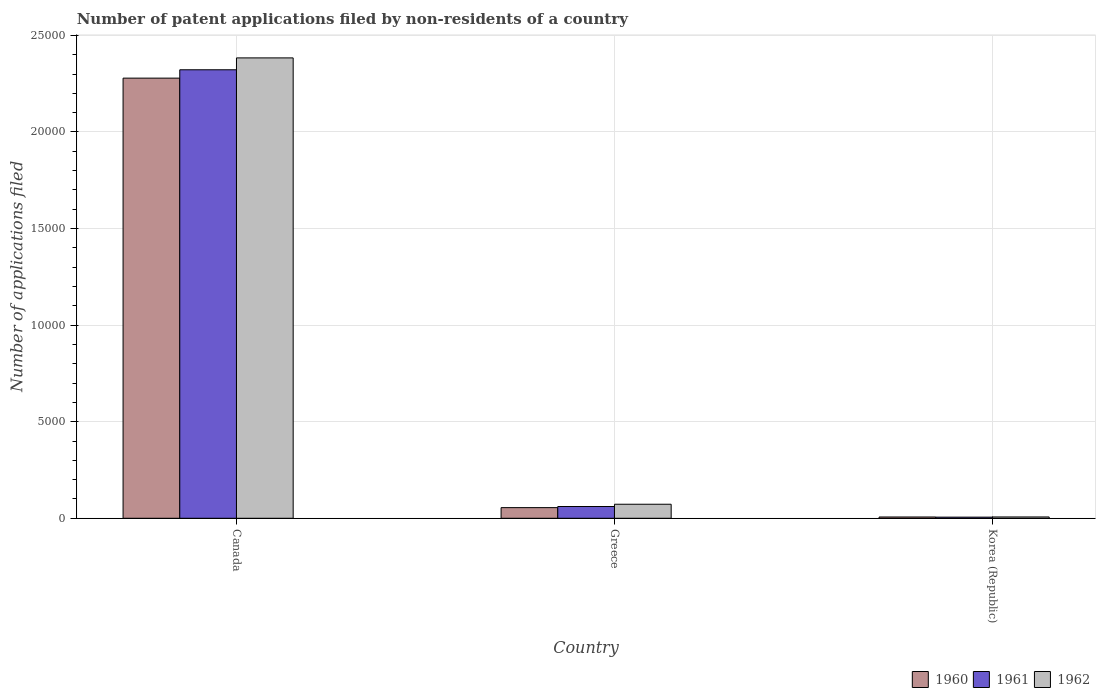How many different coloured bars are there?
Ensure brevity in your answer.  3. Are the number of bars per tick equal to the number of legend labels?
Give a very brief answer. Yes. How many bars are there on the 2nd tick from the left?
Make the answer very short. 3. How many bars are there on the 3rd tick from the right?
Offer a terse response. 3. What is the number of applications filed in 1960 in Canada?
Provide a short and direct response. 2.28e+04. Across all countries, what is the maximum number of applications filed in 1962?
Keep it short and to the point. 2.38e+04. Across all countries, what is the minimum number of applications filed in 1960?
Keep it short and to the point. 66. What is the total number of applications filed in 1960 in the graph?
Give a very brief answer. 2.34e+04. What is the difference between the number of applications filed in 1962 in Canada and that in Greece?
Offer a terse response. 2.31e+04. What is the difference between the number of applications filed in 1960 in Greece and the number of applications filed in 1961 in Korea (Republic)?
Your answer should be very brief. 493. What is the average number of applications filed in 1962 per country?
Your answer should be very brief. 8209.33. What is the difference between the number of applications filed of/in 1961 and number of applications filed of/in 1962 in Canada?
Ensure brevity in your answer.  -615. In how many countries, is the number of applications filed in 1962 greater than 15000?
Give a very brief answer. 1. What is the ratio of the number of applications filed in 1960 in Canada to that in Greece?
Provide a succinct answer. 41.35. Is the number of applications filed in 1962 in Canada less than that in Korea (Republic)?
Make the answer very short. No. What is the difference between the highest and the second highest number of applications filed in 1960?
Give a very brief answer. 2.27e+04. What is the difference between the highest and the lowest number of applications filed in 1960?
Your answer should be compact. 2.27e+04. In how many countries, is the number of applications filed in 1961 greater than the average number of applications filed in 1961 taken over all countries?
Your answer should be very brief. 1. Is the sum of the number of applications filed in 1960 in Canada and Korea (Republic) greater than the maximum number of applications filed in 1962 across all countries?
Your answer should be compact. No. What does the 3rd bar from the right in Greece represents?
Your answer should be compact. 1960. Is it the case that in every country, the sum of the number of applications filed in 1960 and number of applications filed in 1962 is greater than the number of applications filed in 1961?
Offer a terse response. Yes. How many bars are there?
Provide a short and direct response. 9. How many countries are there in the graph?
Ensure brevity in your answer.  3. What is the difference between two consecutive major ticks on the Y-axis?
Your answer should be very brief. 5000. Are the values on the major ticks of Y-axis written in scientific E-notation?
Make the answer very short. No. Where does the legend appear in the graph?
Provide a short and direct response. Bottom right. What is the title of the graph?
Give a very brief answer. Number of patent applications filed by non-residents of a country. Does "2001" appear as one of the legend labels in the graph?
Your answer should be compact. No. What is the label or title of the X-axis?
Offer a terse response. Country. What is the label or title of the Y-axis?
Keep it short and to the point. Number of applications filed. What is the Number of applications filed of 1960 in Canada?
Provide a succinct answer. 2.28e+04. What is the Number of applications filed in 1961 in Canada?
Offer a terse response. 2.32e+04. What is the Number of applications filed in 1962 in Canada?
Your answer should be compact. 2.38e+04. What is the Number of applications filed of 1960 in Greece?
Make the answer very short. 551. What is the Number of applications filed of 1961 in Greece?
Offer a very short reply. 609. What is the Number of applications filed of 1962 in Greece?
Ensure brevity in your answer.  726. What is the Number of applications filed of 1962 in Korea (Republic)?
Keep it short and to the point. 68. Across all countries, what is the maximum Number of applications filed in 1960?
Provide a succinct answer. 2.28e+04. Across all countries, what is the maximum Number of applications filed of 1961?
Give a very brief answer. 2.32e+04. Across all countries, what is the maximum Number of applications filed in 1962?
Give a very brief answer. 2.38e+04. Across all countries, what is the minimum Number of applications filed in 1961?
Provide a short and direct response. 58. What is the total Number of applications filed of 1960 in the graph?
Give a very brief answer. 2.34e+04. What is the total Number of applications filed in 1961 in the graph?
Provide a short and direct response. 2.39e+04. What is the total Number of applications filed of 1962 in the graph?
Offer a terse response. 2.46e+04. What is the difference between the Number of applications filed of 1960 in Canada and that in Greece?
Make the answer very short. 2.22e+04. What is the difference between the Number of applications filed in 1961 in Canada and that in Greece?
Make the answer very short. 2.26e+04. What is the difference between the Number of applications filed of 1962 in Canada and that in Greece?
Offer a very short reply. 2.31e+04. What is the difference between the Number of applications filed of 1960 in Canada and that in Korea (Republic)?
Offer a very short reply. 2.27e+04. What is the difference between the Number of applications filed of 1961 in Canada and that in Korea (Republic)?
Provide a succinct answer. 2.32e+04. What is the difference between the Number of applications filed in 1962 in Canada and that in Korea (Republic)?
Offer a very short reply. 2.38e+04. What is the difference between the Number of applications filed in 1960 in Greece and that in Korea (Republic)?
Ensure brevity in your answer.  485. What is the difference between the Number of applications filed of 1961 in Greece and that in Korea (Republic)?
Offer a terse response. 551. What is the difference between the Number of applications filed of 1962 in Greece and that in Korea (Republic)?
Give a very brief answer. 658. What is the difference between the Number of applications filed in 1960 in Canada and the Number of applications filed in 1961 in Greece?
Give a very brief answer. 2.22e+04. What is the difference between the Number of applications filed in 1960 in Canada and the Number of applications filed in 1962 in Greece?
Offer a terse response. 2.21e+04. What is the difference between the Number of applications filed of 1961 in Canada and the Number of applications filed of 1962 in Greece?
Offer a very short reply. 2.25e+04. What is the difference between the Number of applications filed in 1960 in Canada and the Number of applications filed in 1961 in Korea (Republic)?
Offer a very short reply. 2.27e+04. What is the difference between the Number of applications filed in 1960 in Canada and the Number of applications filed in 1962 in Korea (Republic)?
Keep it short and to the point. 2.27e+04. What is the difference between the Number of applications filed of 1961 in Canada and the Number of applications filed of 1962 in Korea (Republic)?
Provide a short and direct response. 2.32e+04. What is the difference between the Number of applications filed of 1960 in Greece and the Number of applications filed of 1961 in Korea (Republic)?
Provide a short and direct response. 493. What is the difference between the Number of applications filed in 1960 in Greece and the Number of applications filed in 1962 in Korea (Republic)?
Ensure brevity in your answer.  483. What is the difference between the Number of applications filed in 1961 in Greece and the Number of applications filed in 1962 in Korea (Republic)?
Your answer should be compact. 541. What is the average Number of applications filed of 1960 per country?
Keep it short and to the point. 7801. What is the average Number of applications filed of 1961 per country?
Provide a short and direct response. 7962. What is the average Number of applications filed in 1962 per country?
Offer a terse response. 8209.33. What is the difference between the Number of applications filed of 1960 and Number of applications filed of 1961 in Canada?
Keep it short and to the point. -433. What is the difference between the Number of applications filed of 1960 and Number of applications filed of 1962 in Canada?
Provide a succinct answer. -1048. What is the difference between the Number of applications filed in 1961 and Number of applications filed in 1962 in Canada?
Keep it short and to the point. -615. What is the difference between the Number of applications filed in 1960 and Number of applications filed in 1961 in Greece?
Offer a very short reply. -58. What is the difference between the Number of applications filed in 1960 and Number of applications filed in 1962 in Greece?
Your answer should be compact. -175. What is the difference between the Number of applications filed in 1961 and Number of applications filed in 1962 in Greece?
Your response must be concise. -117. What is the difference between the Number of applications filed of 1960 and Number of applications filed of 1961 in Korea (Republic)?
Ensure brevity in your answer.  8. What is the difference between the Number of applications filed of 1960 and Number of applications filed of 1962 in Korea (Republic)?
Your answer should be very brief. -2. What is the ratio of the Number of applications filed in 1960 in Canada to that in Greece?
Make the answer very short. 41.35. What is the ratio of the Number of applications filed in 1961 in Canada to that in Greece?
Keep it short and to the point. 38.13. What is the ratio of the Number of applications filed in 1962 in Canada to that in Greece?
Ensure brevity in your answer.  32.83. What is the ratio of the Number of applications filed of 1960 in Canada to that in Korea (Republic)?
Give a very brief answer. 345.24. What is the ratio of the Number of applications filed in 1961 in Canada to that in Korea (Republic)?
Your response must be concise. 400.33. What is the ratio of the Number of applications filed of 1962 in Canada to that in Korea (Republic)?
Offer a terse response. 350.5. What is the ratio of the Number of applications filed of 1960 in Greece to that in Korea (Republic)?
Your response must be concise. 8.35. What is the ratio of the Number of applications filed of 1961 in Greece to that in Korea (Republic)?
Your answer should be very brief. 10.5. What is the ratio of the Number of applications filed in 1962 in Greece to that in Korea (Republic)?
Your answer should be compact. 10.68. What is the difference between the highest and the second highest Number of applications filed of 1960?
Ensure brevity in your answer.  2.22e+04. What is the difference between the highest and the second highest Number of applications filed of 1961?
Your response must be concise. 2.26e+04. What is the difference between the highest and the second highest Number of applications filed in 1962?
Your response must be concise. 2.31e+04. What is the difference between the highest and the lowest Number of applications filed in 1960?
Give a very brief answer. 2.27e+04. What is the difference between the highest and the lowest Number of applications filed of 1961?
Provide a succinct answer. 2.32e+04. What is the difference between the highest and the lowest Number of applications filed in 1962?
Keep it short and to the point. 2.38e+04. 